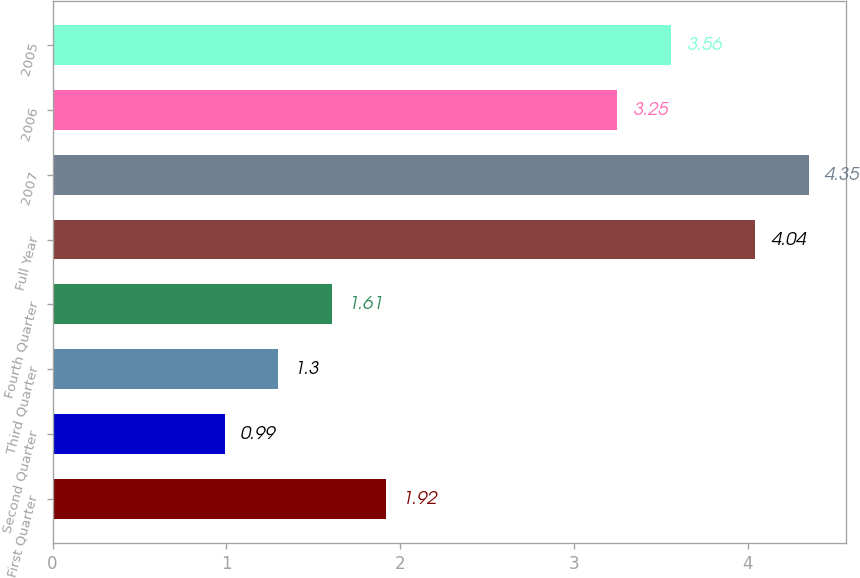Convert chart to OTSL. <chart><loc_0><loc_0><loc_500><loc_500><bar_chart><fcel>First Quarter<fcel>Second Quarter<fcel>Third Quarter<fcel>Fourth Quarter<fcel>Full Year<fcel>2007<fcel>2006<fcel>2005<nl><fcel>1.92<fcel>0.99<fcel>1.3<fcel>1.61<fcel>4.04<fcel>4.35<fcel>3.25<fcel>3.56<nl></chart> 